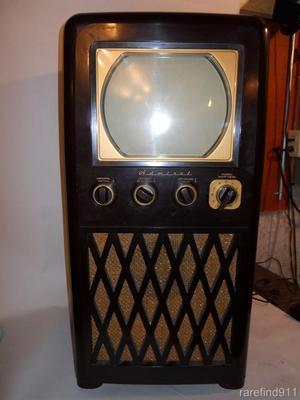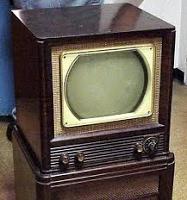The first image is the image on the left, the second image is the image on the right. Analyze the images presented: Is the assertion "At least one image shows a TV screen that is flat on the top and bottom, and curved on the sides." valid? Answer yes or no. Yes. The first image is the image on the left, the second image is the image on the right. Evaluate the accuracy of this statement regarding the images: "Each of two older television sets is in a wooden case with a gold tone rim around the picture tube, and two or four control knobs underneath.". Is it true? Answer yes or no. Yes. 